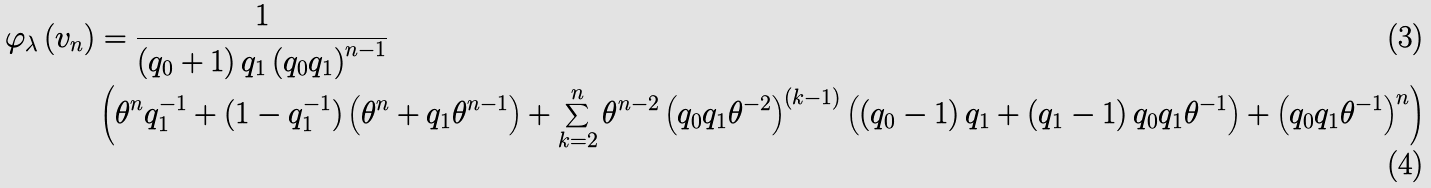<formula> <loc_0><loc_0><loc_500><loc_500>\varphi _ { \lambda } \left ( v _ { n } \right ) & = \frac { 1 } { \left ( q _ { 0 } + 1 \right ) q _ { 1 } \left ( q _ { 0 } q _ { 1 } \right ) ^ { n - 1 } } \\ & \left ( \theta ^ { n } q _ { 1 } ^ { - 1 } + ( 1 - q _ { 1 } ^ { - 1 } ) \left ( \theta ^ { n } + q _ { 1 } \theta ^ { n - 1 } \right ) + \sum _ { k = 2 } ^ { n } \theta ^ { n - 2 } \left ( q _ { 0 } q _ { 1 } \theta ^ { - 2 } \right ) ^ { \left ( k - 1 \right ) } \left ( \left ( q _ { 0 } - 1 \right ) q _ { 1 } + \left ( q _ { 1 } - 1 \right ) q _ { 0 } q _ { 1 } \theta ^ { - 1 } \right ) + \left ( q _ { 0 } q _ { 1 } \theta ^ { - 1 } \right ) ^ { n } \right )</formula> 